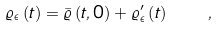Convert formula to latex. <formula><loc_0><loc_0><loc_500><loc_500>\varrho _ { \epsilon } \left ( t \right ) = \bar { \varrho } \left ( t , 0 \right ) + \varrho _ { \epsilon } ^ { \prime } \left ( t \right ) \quad ,</formula> 